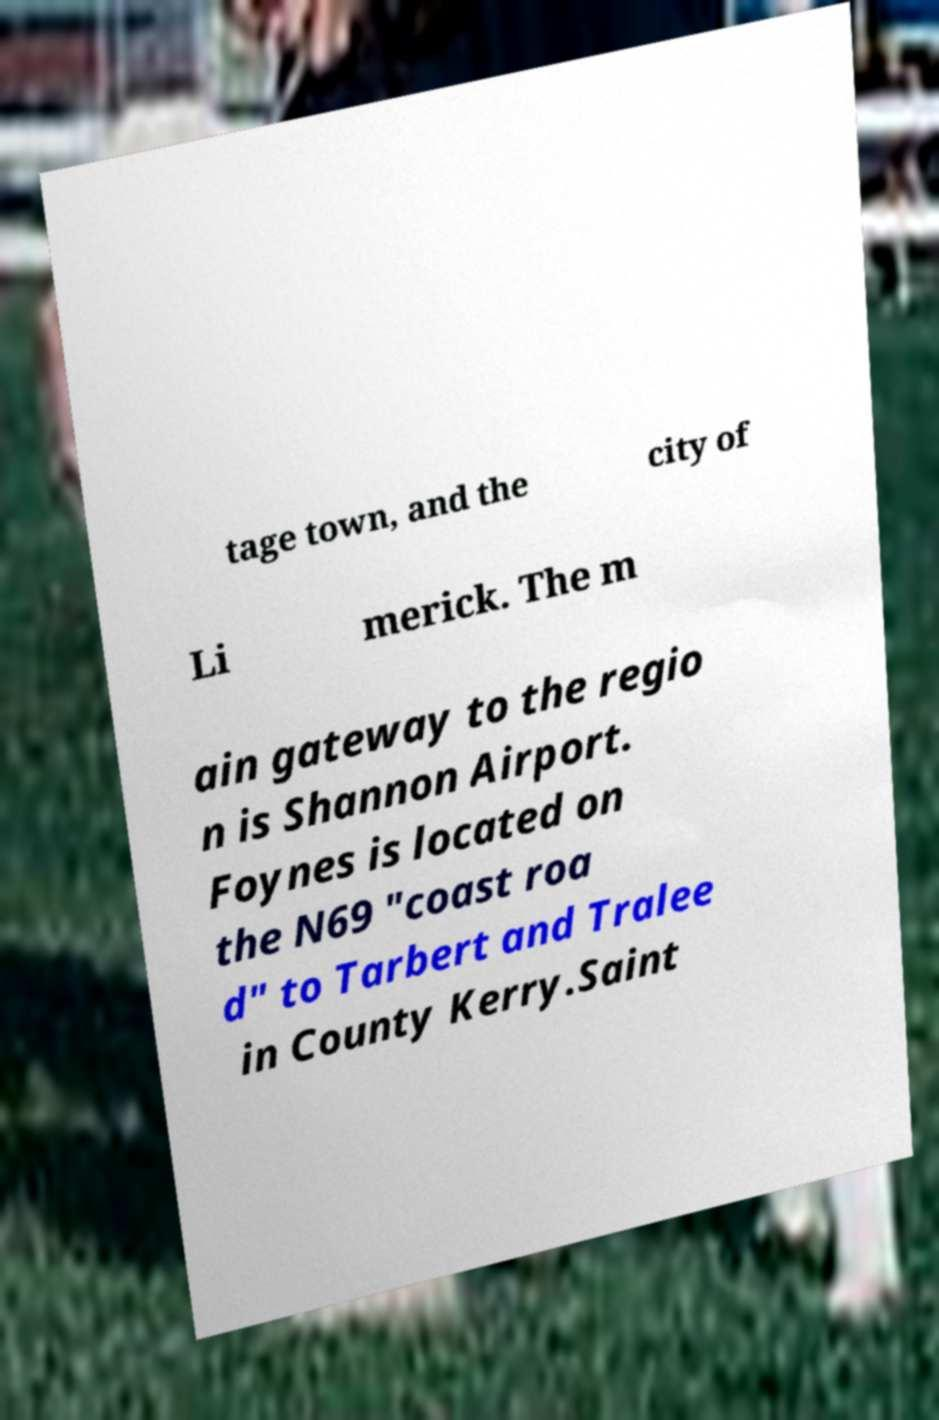Can you accurately transcribe the text from the provided image for me? tage town, and the city of Li merick. The m ain gateway to the regio n is Shannon Airport. Foynes is located on the N69 "coast roa d" to Tarbert and Tralee in County Kerry.Saint 